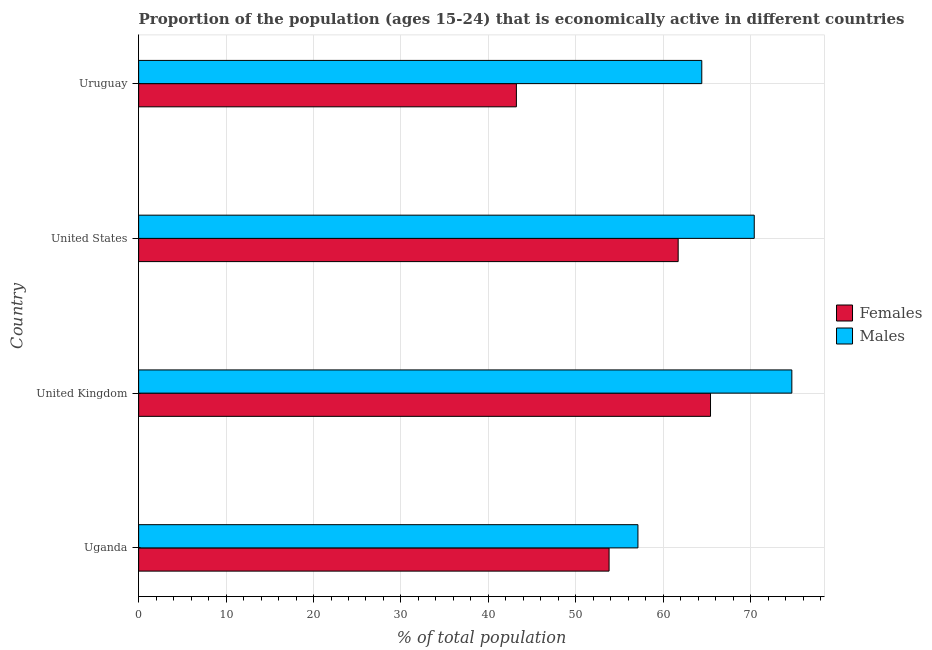How many different coloured bars are there?
Give a very brief answer. 2. How many groups of bars are there?
Make the answer very short. 4. Are the number of bars on each tick of the Y-axis equal?
Your answer should be compact. Yes. What is the label of the 4th group of bars from the top?
Ensure brevity in your answer.  Uganda. In how many cases, is the number of bars for a given country not equal to the number of legend labels?
Make the answer very short. 0. What is the percentage of economically active female population in Uruguay?
Your response must be concise. 43.2. Across all countries, what is the maximum percentage of economically active female population?
Offer a very short reply. 65.4. Across all countries, what is the minimum percentage of economically active female population?
Give a very brief answer. 43.2. In which country was the percentage of economically active female population minimum?
Keep it short and to the point. Uruguay. What is the total percentage of economically active female population in the graph?
Give a very brief answer. 224.1. What is the difference between the percentage of economically active female population in United Kingdom and the percentage of economically active male population in Uruguay?
Offer a terse response. 1. What is the average percentage of economically active female population per country?
Your response must be concise. 56.02. What is the ratio of the percentage of economically active female population in United Kingdom to that in Uruguay?
Offer a terse response. 1.51. Is the percentage of economically active male population in Uganda less than that in United Kingdom?
Provide a short and direct response. Yes. Is the difference between the percentage of economically active male population in United States and Uruguay greater than the difference between the percentage of economically active female population in United States and Uruguay?
Give a very brief answer. No. What is the difference between the highest and the second highest percentage of economically active male population?
Give a very brief answer. 4.3. What is the difference between the highest and the lowest percentage of economically active female population?
Your answer should be very brief. 22.2. In how many countries, is the percentage of economically active male population greater than the average percentage of economically active male population taken over all countries?
Your response must be concise. 2. What does the 1st bar from the top in Uruguay represents?
Make the answer very short. Males. What does the 2nd bar from the bottom in Uganda represents?
Keep it short and to the point. Males. How many bars are there?
Your answer should be very brief. 8. Are all the bars in the graph horizontal?
Your response must be concise. Yes. How many countries are there in the graph?
Offer a very short reply. 4. What is the difference between two consecutive major ticks on the X-axis?
Your answer should be very brief. 10. Does the graph contain any zero values?
Your answer should be compact. No. Where does the legend appear in the graph?
Ensure brevity in your answer.  Center right. How are the legend labels stacked?
Provide a short and direct response. Vertical. What is the title of the graph?
Keep it short and to the point. Proportion of the population (ages 15-24) that is economically active in different countries. What is the label or title of the X-axis?
Provide a succinct answer. % of total population. What is the label or title of the Y-axis?
Make the answer very short. Country. What is the % of total population of Females in Uganda?
Keep it short and to the point. 53.8. What is the % of total population in Males in Uganda?
Make the answer very short. 57.1. What is the % of total population of Females in United Kingdom?
Your response must be concise. 65.4. What is the % of total population in Males in United Kingdom?
Offer a very short reply. 74.7. What is the % of total population in Females in United States?
Provide a succinct answer. 61.7. What is the % of total population in Males in United States?
Provide a short and direct response. 70.4. What is the % of total population of Females in Uruguay?
Provide a succinct answer. 43.2. What is the % of total population of Males in Uruguay?
Offer a very short reply. 64.4. Across all countries, what is the maximum % of total population in Females?
Ensure brevity in your answer.  65.4. Across all countries, what is the maximum % of total population in Males?
Your answer should be compact. 74.7. Across all countries, what is the minimum % of total population of Females?
Your answer should be compact. 43.2. Across all countries, what is the minimum % of total population in Males?
Keep it short and to the point. 57.1. What is the total % of total population in Females in the graph?
Give a very brief answer. 224.1. What is the total % of total population in Males in the graph?
Make the answer very short. 266.6. What is the difference between the % of total population in Males in Uganda and that in United Kingdom?
Give a very brief answer. -17.6. What is the difference between the % of total population in Females in Uganda and that in United States?
Your answer should be very brief. -7.9. What is the difference between the % of total population in Males in Uganda and that in United States?
Your answer should be very brief. -13.3. What is the difference between the % of total population in Females in Uganda and that in Uruguay?
Your answer should be very brief. 10.6. What is the difference between the % of total population in Females in United Kingdom and that in United States?
Your answer should be very brief. 3.7. What is the difference between the % of total population of Males in United States and that in Uruguay?
Ensure brevity in your answer.  6. What is the difference between the % of total population of Females in Uganda and the % of total population of Males in United Kingdom?
Make the answer very short. -20.9. What is the difference between the % of total population in Females in Uganda and the % of total population in Males in United States?
Make the answer very short. -16.6. What is the difference between the % of total population in Females in Uganda and the % of total population in Males in Uruguay?
Make the answer very short. -10.6. What is the difference between the % of total population of Females in United Kingdom and the % of total population of Males in United States?
Keep it short and to the point. -5. What is the difference between the % of total population in Females in United States and the % of total population in Males in Uruguay?
Provide a short and direct response. -2.7. What is the average % of total population in Females per country?
Provide a short and direct response. 56.02. What is the average % of total population in Males per country?
Ensure brevity in your answer.  66.65. What is the difference between the % of total population of Females and % of total population of Males in United Kingdom?
Make the answer very short. -9.3. What is the difference between the % of total population in Females and % of total population in Males in United States?
Make the answer very short. -8.7. What is the difference between the % of total population of Females and % of total population of Males in Uruguay?
Offer a terse response. -21.2. What is the ratio of the % of total population in Females in Uganda to that in United Kingdom?
Provide a short and direct response. 0.82. What is the ratio of the % of total population in Males in Uganda to that in United Kingdom?
Make the answer very short. 0.76. What is the ratio of the % of total population of Females in Uganda to that in United States?
Your answer should be very brief. 0.87. What is the ratio of the % of total population of Males in Uganda to that in United States?
Make the answer very short. 0.81. What is the ratio of the % of total population in Females in Uganda to that in Uruguay?
Provide a short and direct response. 1.25. What is the ratio of the % of total population of Males in Uganda to that in Uruguay?
Provide a short and direct response. 0.89. What is the ratio of the % of total population of Females in United Kingdom to that in United States?
Make the answer very short. 1.06. What is the ratio of the % of total population in Males in United Kingdom to that in United States?
Your response must be concise. 1.06. What is the ratio of the % of total population of Females in United Kingdom to that in Uruguay?
Your response must be concise. 1.51. What is the ratio of the % of total population in Males in United Kingdom to that in Uruguay?
Provide a short and direct response. 1.16. What is the ratio of the % of total population in Females in United States to that in Uruguay?
Offer a very short reply. 1.43. What is the ratio of the % of total population in Males in United States to that in Uruguay?
Offer a very short reply. 1.09. What is the difference between the highest and the second highest % of total population in Females?
Your answer should be very brief. 3.7. What is the difference between the highest and the second highest % of total population in Males?
Offer a very short reply. 4.3. What is the difference between the highest and the lowest % of total population of Females?
Keep it short and to the point. 22.2. What is the difference between the highest and the lowest % of total population in Males?
Your response must be concise. 17.6. 